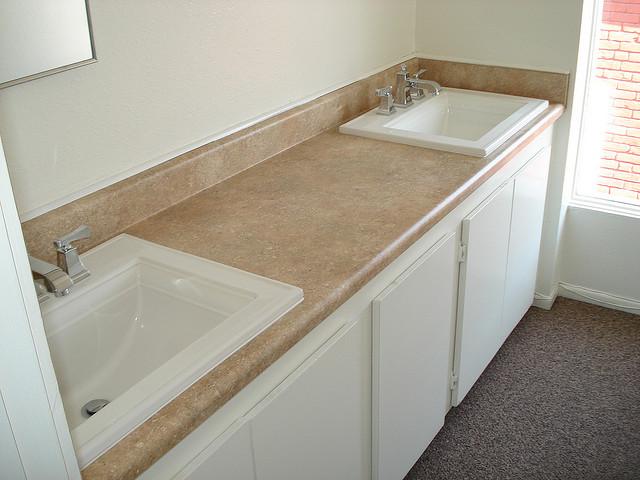What is the floor made of?
Be succinct. Carpet. Do these sinks appear clean?
Concise answer only. Yes. Can you see any furniture?
Short answer required. No. How many sinks in the room?
Give a very brief answer. 2. 